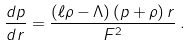Convert formula to latex. <formula><loc_0><loc_0><loc_500><loc_500>\frac { d p } { d r } = \frac { ( \ell \rho - \Lambda ) \, ( p + \rho ) \, r } { F ^ { 2 } } \, .</formula> 